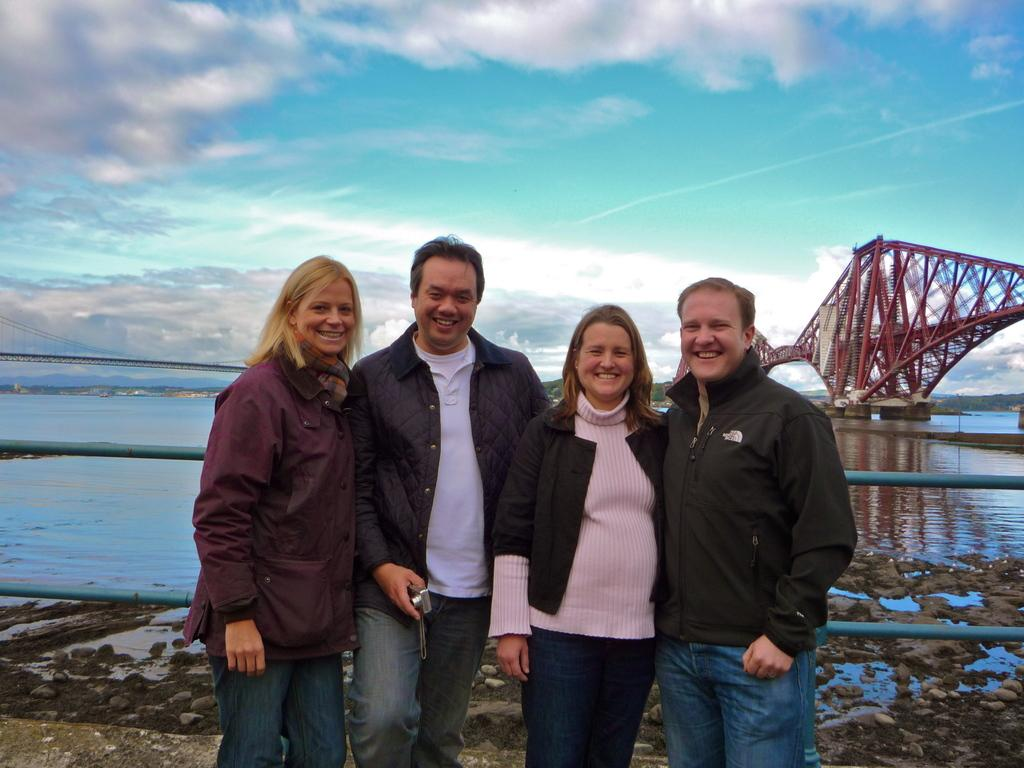How many people are in the image? There are four persons in the image. What is one of the persons doing? One of the persons is holding a camera. What is located behind the persons? There is a bridge behind the persons. What type of natural elements can be seen in the image? There are rocks and water visible in the image. How would you describe the weather in the image? The sky is cloudy in the image. What type of pan can be seen in the image? There is no pan present in the image. Are there any corn plants visible in the image? There are no corn plants visible in the image. 